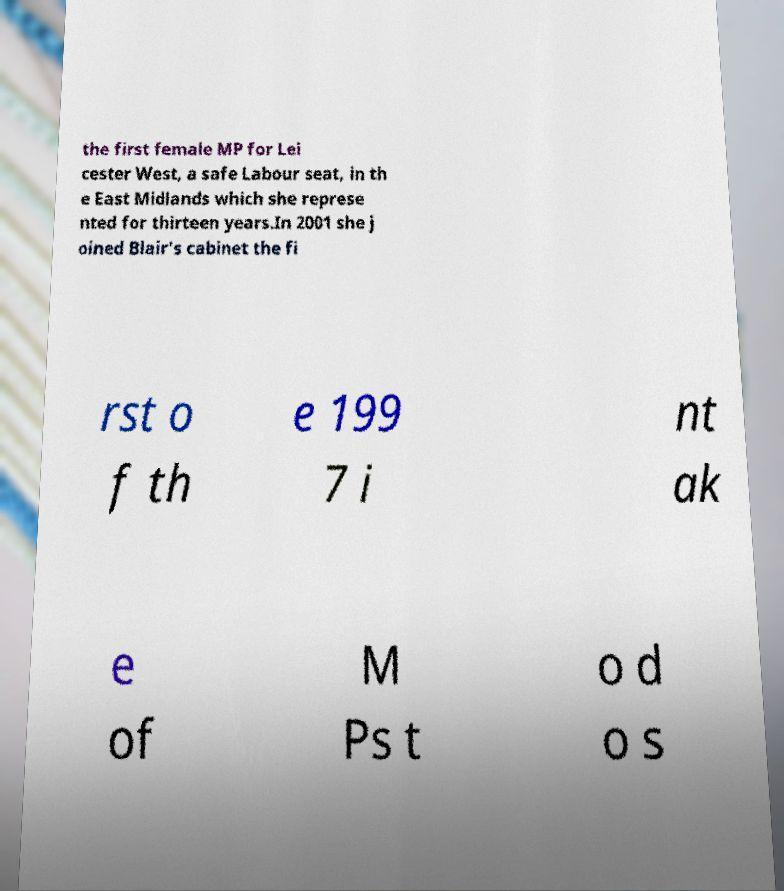Can you read and provide the text displayed in the image?This photo seems to have some interesting text. Can you extract and type it out for me? the first female MP for Lei cester West, a safe Labour seat, in th e East Midlands which she represe nted for thirteen years.In 2001 she j oined Blair's cabinet the fi rst o f th e 199 7 i nt ak e of M Ps t o d o s 